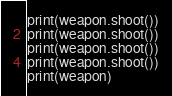Convert code to text. <code><loc_0><loc_0><loc_500><loc_500><_Python_>print(weapon.shoot())
print(weapon.shoot())
print(weapon.shoot())
print(weapon.shoot())
print(weapon)
</code> 